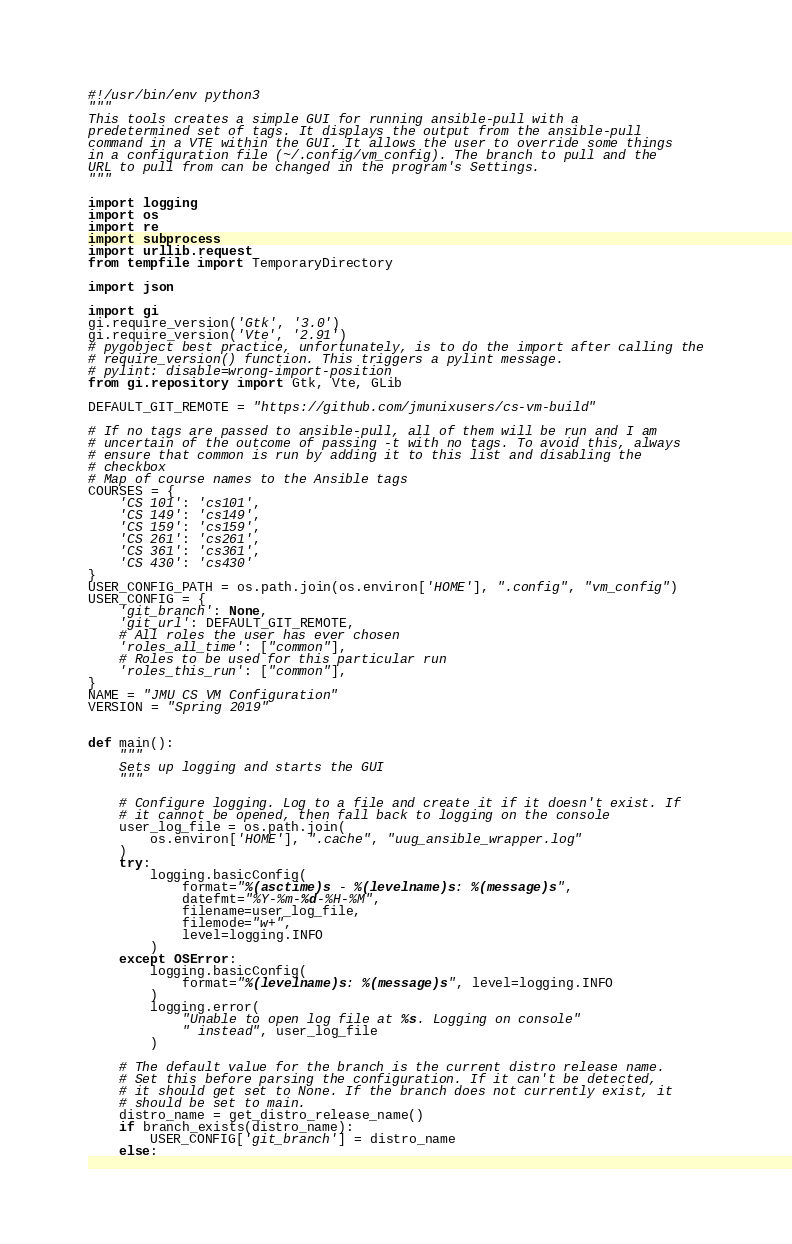Convert code to text. <code><loc_0><loc_0><loc_500><loc_500><_Python_>#!/usr/bin/env python3
"""
This tools creates a simple GUI for running ansible-pull with a
predetermined set of tags. It displays the output from the ansible-pull
command in a VTE within the GUI. It allows the user to override some things
in a configuration file (~/.config/vm_config). The branch to pull and the
URL to pull from can be changed in the program's Settings.
"""

import logging
import os
import re
import subprocess
import urllib.request
from tempfile import TemporaryDirectory

import json

import gi
gi.require_version('Gtk', '3.0')
gi.require_version('Vte', '2.91')
# pygobject best practice, unfortunately, is to do the import after calling the
# require_version() function. This triggers a pylint message.
# pylint: disable=wrong-import-position
from gi.repository import Gtk, Vte, GLib

DEFAULT_GIT_REMOTE = "https://github.com/jmunixusers/cs-vm-build"

# If no tags are passed to ansible-pull, all of them will be run and I am
# uncertain of the outcome of passing -t with no tags. To avoid this, always
# ensure that common is run by adding it to this list and disabling the
# checkbox
# Map of course names to the Ansible tags
COURSES = {
    'CS 101': 'cs101',
    'CS 149': 'cs149',
    'CS 159': 'cs159',
    'CS 261': 'cs261',
    'CS 361': 'cs361',
    'CS 430': 'cs430'
}
USER_CONFIG_PATH = os.path.join(os.environ['HOME'], ".config", "vm_config")
USER_CONFIG = {
    'git_branch': None,
    'git_url': DEFAULT_GIT_REMOTE,
    # All roles the user has ever chosen
    'roles_all_time': ["common"],
    # Roles to be used for this particular run
    'roles_this_run': ["common"],
}
NAME = "JMU CS VM Configuration"
VERSION = "Spring 2019"


def main():
    """
    Sets up logging and starts the GUI
    """

    # Configure logging. Log to a file and create it if it doesn't exist. If
    # it cannot be opened, then fall back to logging on the console
    user_log_file = os.path.join(
        os.environ['HOME'], ".cache", "uug_ansible_wrapper.log"
    )
    try:
        logging.basicConfig(
            format="%(asctime)s - %(levelname)s: %(message)s",
            datefmt="%Y-%m-%d-%H-%M",
            filename=user_log_file,
            filemode="w+",
            level=logging.INFO
        )
    except OSError:
        logging.basicConfig(
            format="%(levelname)s: %(message)s", level=logging.INFO
        )
        logging.error(
            "Unable to open log file at %s. Logging on console"
            " instead", user_log_file
        )

    # The default value for the branch is the current distro release name.
    # Set this before parsing the configuration. If it can't be detected,
    # it should get set to None. If the branch does not currently exist, it
    # should be set to main.
    distro_name = get_distro_release_name()
    if branch_exists(distro_name):
        USER_CONFIG['git_branch'] = distro_name
    else:</code> 